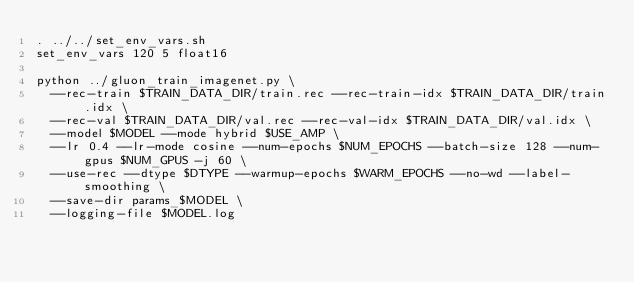Convert code to text. <code><loc_0><loc_0><loc_500><loc_500><_Bash_>. ../../set_env_vars.sh
set_env_vars 120 5 float16

python ../gluon_train_imagenet.py \
  --rec-train $TRAIN_DATA_DIR/train.rec --rec-train-idx $TRAIN_DATA_DIR/train.idx \
  --rec-val $TRAIN_DATA_DIR/val.rec --rec-val-idx $TRAIN_DATA_DIR/val.idx \
  --model $MODEL --mode hybrid $USE_AMP \
  --lr 0.4 --lr-mode cosine --num-epochs $NUM_EPOCHS --batch-size 128 --num-gpus $NUM_GPUS -j 60 \
  --use-rec --dtype $DTYPE --warmup-epochs $WARM_EPOCHS --no-wd --label-smoothing \
  --save-dir params_$MODEL \
  --logging-file $MODEL.log


</code> 